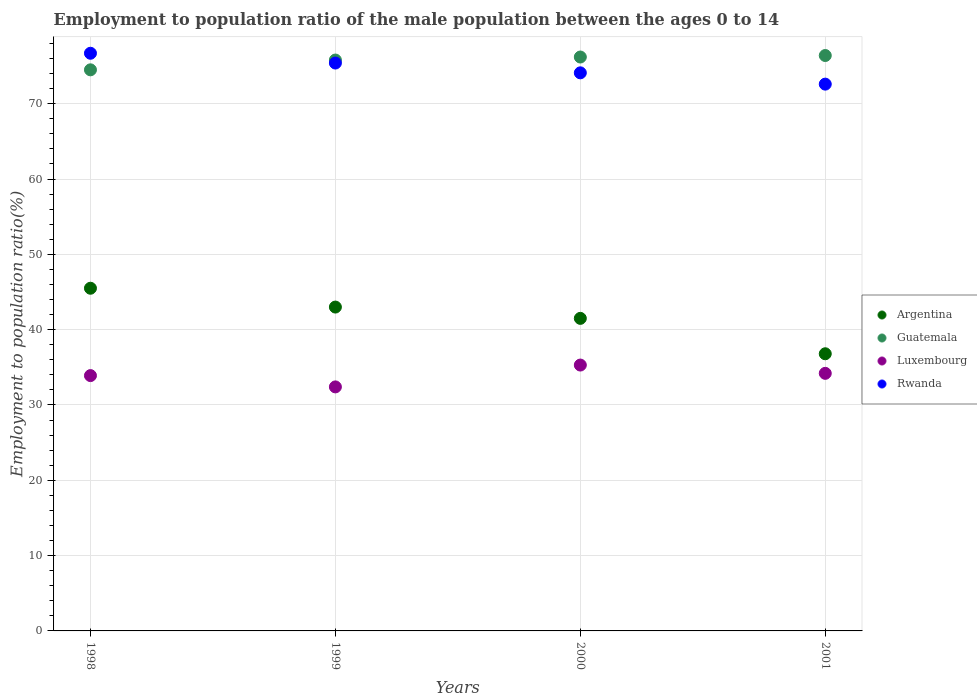What is the employment to population ratio in Argentina in 1998?
Offer a terse response. 45.5. Across all years, what is the maximum employment to population ratio in Rwanda?
Provide a short and direct response. 76.7. Across all years, what is the minimum employment to population ratio in Rwanda?
Your response must be concise. 72.6. In which year was the employment to population ratio in Argentina maximum?
Offer a very short reply. 1998. What is the total employment to population ratio in Luxembourg in the graph?
Your response must be concise. 135.8. What is the difference between the employment to population ratio in Rwanda in 1998 and that in 2001?
Offer a very short reply. 4.1. What is the difference between the employment to population ratio in Argentina in 1998 and the employment to population ratio in Guatemala in 2000?
Give a very brief answer. -30.7. What is the average employment to population ratio in Guatemala per year?
Provide a succinct answer. 75.73. In the year 1999, what is the difference between the employment to population ratio in Guatemala and employment to population ratio in Rwanda?
Offer a terse response. 0.4. In how many years, is the employment to population ratio in Argentina greater than 66 %?
Give a very brief answer. 0. What is the ratio of the employment to population ratio in Rwanda in 1998 to that in 2000?
Keep it short and to the point. 1.04. Is the employment to population ratio in Guatemala in 2000 less than that in 2001?
Provide a succinct answer. Yes. Is the difference between the employment to population ratio in Guatemala in 1998 and 1999 greater than the difference between the employment to population ratio in Rwanda in 1998 and 1999?
Give a very brief answer. No. What is the difference between the highest and the second highest employment to population ratio in Guatemala?
Provide a succinct answer. 0.2. What is the difference between the highest and the lowest employment to population ratio in Rwanda?
Provide a succinct answer. 4.1. Is it the case that in every year, the sum of the employment to population ratio in Argentina and employment to population ratio in Luxembourg  is greater than the employment to population ratio in Rwanda?
Offer a terse response. No. Are the values on the major ticks of Y-axis written in scientific E-notation?
Offer a terse response. No. Where does the legend appear in the graph?
Make the answer very short. Center right. What is the title of the graph?
Provide a short and direct response. Employment to population ratio of the male population between the ages 0 to 14. Does "Montenegro" appear as one of the legend labels in the graph?
Keep it short and to the point. No. What is the Employment to population ratio(%) of Argentina in 1998?
Provide a short and direct response. 45.5. What is the Employment to population ratio(%) in Guatemala in 1998?
Make the answer very short. 74.5. What is the Employment to population ratio(%) in Luxembourg in 1998?
Offer a very short reply. 33.9. What is the Employment to population ratio(%) of Rwanda in 1998?
Your response must be concise. 76.7. What is the Employment to population ratio(%) in Argentina in 1999?
Make the answer very short. 43. What is the Employment to population ratio(%) of Guatemala in 1999?
Your answer should be compact. 75.8. What is the Employment to population ratio(%) of Luxembourg in 1999?
Offer a very short reply. 32.4. What is the Employment to population ratio(%) in Rwanda in 1999?
Ensure brevity in your answer.  75.4. What is the Employment to population ratio(%) of Argentina in 2000?
Make the answer very short. 41.5. What is the Employment to population ratio(%) in Guatemala in 2000?
Your answer should be very brief. 76.2. What is the Employment to population ratio(%) in Luxembourg in 2000?
Provide a short and direct response. 35.3. What is the Employment to population ratio(%) in Rwanda in 2000?
Give a very brief answer. 74.1. What is the Employment to population ratio(%) in Argentina in 2001?
Give a very brief answer. 36.8. What is the Employment to population ratio(%) of Guatemala in 2001?
Your answer should be very brief. 76.4. What is the Employment to population ratio(%) of Luxembourg in 2001?
Keep it short and to the point. 34.2. What is the Employment to population ratio(%) in Rwanda in 2001?
Make the answer very short. 72.6. Across all years, what is the maximum Employment to population ratio(%) of Argentina?
Provide a succinct answer. 45.5. Across all years, what is the maximum Employment to population ratio(%) of Guatemala?
Provide a succinct answer. 76.4. Across all years, what is the maximum Employment to population ratio(%) in Luxembourg?
Make the answer very short. 35.3. Across all years, what is the maximum Employment to population ratio(%) of Rwanda?
Your answer should be very brief. 76.7. Across all years, what is the minimum Employment to population ratio(%) of Argentina?
Your answer should be compact. 36.8. Across all years, what is the minimum Employment to population ratio(%) of Guatemala?
Ensure brevity in your answer.  74.5. Across all years, what is the minimum Employment to population ratio(%) in Luxembourg?
Your answer should be compact. 32.4. Across all years, what is the minimum Employment to population ratio(%) of Rwanda?
Your response must be concise. 72.6. What is the total Employment to population ratio(%) of Argentina in the graph?
Offer a terse response. 166.8. What is the total Employment to population ratio(%) of Guatemala in the graph?
Provide a succinct answer. 302.9. What is the total Employment to population ratio(%) in Luxembourg in the graph?
Make the answer very short. 135.8. What is the total Employment to population ratio(%) in Rwanda in the graph?
Offer a very short reply. 298.8. What is the difference between the Employment to population ratio(%) in Luxembourg in 1998 and that in 1999?
Keep it short and to the point. 1.5. What is the difference between the Employment to population ratio(%) of Argentina in 1998 and that in 2000?
Ensure brevity in your answer.  4. What is the difference between the Employment to population ratio(%) in Guatemala in 1998 and that in 2000?
Your answer should be compact. -1.7. What is the difference between the Employment to population ratio(%) in Luxembourg in 1998 and that in 2000?
Your response must be concise. -1.4. What is the difference between the Employment to population ratio(%) in Rwanda in 1998 and that in 2000?
Your answer should be very brief. 2.6. What is the difference between the Employment to population ratio(%) of Argentina in 1998 and that in 2001?
Provide a succinct answer. 8.7. What is the difference between the Employment to population ratio(%) in Guatemala in 1998 and that in 2001?
Offer a terse response. -1.9. What is the difference between the Employment to population ratio(%) in Luxembourg in 1998 and that in 2001?
Offer a terse response. -0.3. What is the difference between the Employment to population ratio(%) in Rwanda in 1998 and that in 2001?
Ensure brevity in your answer.  4.1. What is the difference between the Employment to population ratio(%) in Luxembourg in 1999 and that in 2000?
Make the answer very short. -2.9. What is the difference between the Employment to population ratio(%) of Luxembourg in 1999 and that in 2001?
Offer a terse response. -1.8. What is the difference between the Employment to population ratio(%) in Rwanda in 1999 and that in 2001?
Give a very brief answer. 2.8. What is the difference between the Employment to population ratio(%) in Guatemala in 2000 and that in 2001?
Provide a succinct answer. -0.2. What is the difference between the Employment to population ratio(%) of Luxembourg in 2000 and that in 2001?
Give a very brief answer. 1.1. What is the difference between the Employment to population ratio(%) of Rwanda in 2000 and that in 2001?
Provide a succinct answer. 1.5. What is the difference between the Employment to population ratio(%) in Argentina in 1998 and the Employment to population ratio(%) in Guatemala in 1999?
Offer a terse response. -30.3. What is the difference between the Employment to population ratio(%) of Argentina in 1998 and the Employment to population ratio(%) of Rwanda in 1999?
Offer a very short reply. -29.9. What is the difference between the Employment to population ratio(%) of Guatemala in 1998 and the Employment to population ratio(%) of Luxembourg in 1999?
Your response must be concise. 42.1. What is the difference between the Employment to population ratio(%) of Guatemala in 1998 and the Employment to population ratio(%) of Rwanda in 1999?
Ensure brevity in your answer.  -0.9. What is the difference between the Employment to population ratio(%) of Luxembourg in 1998 and the Employment to population ratio(%) of Rwanda in 1999?
Your response must be concise. -41.5. What is the difference between the Employment to population ratio(%) in Argentina in 1998 and the Employment to population ratio(%) in Guatemala in 2000?
Provide a short and direct response. -30.7. What is the difference between the Employment to population ratio(%) in Argentina in 1998 and the Employment to population ratio(%) in Rwanda in 2000?
Ensure brevity in your answer.  -28.6. What is the difference between the Employment to population ratio(%) in Guatemala in 1998 and the Employment to population ratio(%) in Luxembourg in 2000?
Your answer should be very brief. 39.2. What is the difference between the Employment to population ratio(%) of Guatemala in 1998 and the Employment to population ratio(%) of Rwanda in 2000?
Offer a very short reply. 0.4. What is the difference between the Employment to population ratio(%) in Luxembourg in 1998 and the Employment to population ratio(%) in Rwanda in 2000?
Keep it short and to the point. -40.2. What is the difference between the Employment to population ratio(%) in Argentina in 1998 and the Employment to population ratio(%) in Guatemala in 2001?
Your answer should be very brief. -30.9. What is the difference between the Employment to population ratio(%) of Argentina in 1998 and the Employment to population ratio(%) of Luxembourg in 2001?
Keep it short and to the point. 11.3. What is the difference between the Employment to population ratio(%) of Argentina in 1998 and the Employment to population ratio(%) of Rwanda in 2001?
Offer a terse response. -27.1. What is the difference between the Employment to population ratio(%) in Guatemala in 1998 and the Employment to population ratio(%) in Luxembourg in 2001?
Provide a short and direct response. 40.3. What is the difference between the Employment to population ratio(%) in Guatemala in 1998 and the Employment to population ratio(%) in Rwanda in 2001?
Provide a succinct answer. 1.9. What is the difference between the Employment to population ratio(%) in Luxembourg in 1998 and the Employment to population ratio(%) in Rwanda in 2001?
Provide a succinct answer. -38.7. What is the difference between the Employment to population ratio(%) in Argentina in 1999 and the Employment to population ratio(%) in Guatemala in 2000?
Keep it short and to the point. -33.2. What is the difference between the Employment to population ratio(%) of Argentina in 1999 and the Employment to population ratio(%) of Rwanda in 2000?
Offer a very short reply. -31.1. What is the difference between the Employment to population ratio(%) in Guatemala in 1999 and the Employment to population ratio(%) in Luxembourg in 2000?
Offer a very short reply. 40.5. What is the difference between the Employment to population ratio(%) in Guatemala in 1999 and the Employment to population ratio(%) in Rwanda in 2000?
Give a very brief answer. 1.7. What is the difference between the Employment to population ratio(%) of Luxembourg in 1999 and the Employment to population ratio(%) of Rwanda in 2000?
Your answer should be very brief. -41.7. What is the difference between the Employment to population ratio(%) of Argentina in 1999 and the Employment to population ratio(%) of Guatemala in 2001?
Your answer should be compact. -33.4. What is the difference between the Employment to population ratio(%) of Argentina in 1999 and the Employment to population ratio(%) of Luxembourg in 2001?
Provide a short and direct response. 8.8. What is the difference between the Employment to population ratio(%) in Argentina in 1999 and the Employment to population ratio(%) in Rwanda in 2001?
Offer a terse response. -29.6. What is the difference between the Employment to population ratio(%) in Guatemala in 1999 and the Employment to population ratio(%) in Luxembourg in 2001?
Provide a short and direct response. 41.6. What is the difference between the Employment to population ratio(%) of Luxembourg in 1999 and the Employment to population ratio(%) of Rwanda in 2001?
Offer a very short reply. -40.2. What is the difference between the Employment to population ratio(%) in Argentina in 2000 and the Employment to population ratio(%) in Guatemala in 2001?
Provide a succinct answer. -34.9. What is the difference between the Employment to population ratio(%) of Argentina in 2000 and the Employment to population ratio(%) of Rwanda in 2001?
Make the answer very short. -31.1. What is the difference between the Employment to population ratio(%) in Guatemala in 2000 and the Employment to population ratio(%) in Luxembourg in 2001?
Ensure brevity in your answer.  42. What is the difference between the Employment to population ratio(%) in Guatemala in 2000 and the Employment to population ratio(%) in Rwanda in 2001?
Provide a succinct answer. 3.6. What is the difference between the Employment to population ratio(%) in Luxembourg in 2000 and the Employment to population ratio(%) in Rwanda in 2001?
Give a very brief answer. -37.3. What is the average Employment to population ratio(%) of Argentina per year?
Offer a terse response. 41.7. What is the average Employment to population ratio(%) of Guatemala per year?
Keep it short and to the point. 75.72. What is the average Employment to population ratio(%) of Luxembourg per year?
Give a very brief answer. 33.95. What is the average Employment to population ratio(%) of Rwanda per year?
Make the answer very short. 74.7. In the year 1998, what is the difference between the Employment to population ratio(%) of Argentina and Employment to population ratio(%) of Rwanda?
Your answer should be very brief. -31.2. In the year 1998, what is the difference between the Employment to population ratio(%) of Guatemala and Employment to population ratio(%) of Luxembourg?
Make the answer very short. 40.6. In the year 1998, what is the difference between the Employment to population ratio(%) of Guatemala and Employment to population ratio(%) of Rwanda?
Make the answer very short. -2.2. In the year 1998, what is the difference between the Employment to population ratio(%) of Luxembourg and Employment to population ratio(%) of Rwanda?
Offer a very short reply. -42.8. In the year 1999, what is the difference between the Employment to population ratio(%) in Argentina and Employment to population ratio(%) in Guatemala?
Offer a terse response. -32.8. In the year 1999, what is the difference between the Employment to population ratio(%) of Argentina and Employment to population ratio(%) of Luxembourg?
Give a very brief answer. 10.6. In the year 1999, what is the difference between the Employment to population ratio(%) of Argentina and Employment to population ratio(%) of Rwanda?
Offer a very short reply. -32.4. In the year 1999, what is the difference between the Employment to population ratio(%) of Guatemala and Employment to population ratio(%) of Luxembourg?
Your answer should be very brief. 43.4. In the year 1999, what is the difference between the Employment to population ratio(%) in Guatemala and Employment to population ratio(%) in Rwanda?
Your answer should be compact. 0.4. In the year 1999, what is the difference between the Employment to population ratio(%) of Luxembourg and Employment to population ratio(%) of Rwanda?
Offer a very short reply. -43. In the year 2000, what is the difference between the Employment to population ratio(%) in Argentina and Employment to population ratio(%) in Guatemala?
Your response must be concise. -34.7. In the year 2000, what is the difference between the Employment to population ratio(%) in Argentina and Employment to population ratio(%) in Rwanda?
Offer a terse response. -32.6. In the year 2000, what is the difference between the Employment to population ratio(%) in Guatemala and Employment to population ratio(%) in Luxembourg?
Offer a very short reply. 40.9. In the year 2000, what is the difference between the Employment to population ratio(%) in Luxembourg and Employment to population ratio(%) in Rwanda?
Your response must be concise. -38.8. In the year 2001, what is the difference between the Employment to population ratio(%) of Argentina and Employment to population ratio(%) of Guatemala?
Ensure brevity in your answer.  -39.6. In the year 2001, what is the difference between the Employment to population ratio(%) of Argentina and Employment to population ratio(%) of Luxembourg?
Provide a short and direct response. 2.6. In the year 2001, what is the difference between the Employment to population ratio(%) in Argentina and Employment to population ratio(%) in Rwanda?
Ensure brevity in your answer.  -35.8. In the year 2001, what is the difference between the Employment to population ratio(%) in Guatemala and Employment to population ratio(%) in Luxembourg?
Keep it short and to the point. 42.2. In the year 2001, what is the difference between the Employment to population ratio(%) in Luxembourg and Employment to population ratio(%) in Rwanda?
Keep it short and to the point. -38.4. What is the ratio of the Employment to population ratio(%) of Argentina in 1998 to that in 1999?
Your answer should be very brief. 1.06. What is the ratio of the Employment to population ratio(%) of Guatemala in 1998 to that in 1999?
Your answer should be compact. 0.98. What is the ratio of the Employment to population ratio(%) in Luxembourg in 1998 to that in 1999?
Give a very brief answer. 1.05. What is the ratio of the Employment to population ratio(%) in Rwanda in 1998 to that in 1999?
Your response must be concise. 1.02. What is the ratio of the Employment to population ratio(%) in Argentina in 1998 to that in 2000?
Offer a very short reply. 1.1. What is the ratio of the Employment to population ratio(%) of Guatemala in 1998 to that in 2000?
Provide a succinct answer. 0.98. What is the ratio of the Employment to population ratio(%) in Luxembourg in 1998 to that in 2000?
Offer a terse response. 0.96. What is the ratio of the Employment to population ratio(%) of Rwanda in 1998 to that in 2000?
Keep it short and to the point. 1.04. What is the ratio of the Employment to population ratio(%) of Argentina in 1998 to that in 2001?
Keep it short and to the point. 1.24. What is the ratio of the Employment to population ratio(%) of Guatemala in 1998 to that in 2001?
Provide a succinct answer. 0.98. What is the ratio of the Employment to population ratio(%) of Luxembourg in 1998 to that in 2001?
Your answer should be compact. 0.99. What is the ratio of the Employment to population ratio(%) in Rwanda in 1998 to that in 2001?
Your response must be concise. 1.06. What is the ratio of the Employment to population ratio(%) in Argentina in 1999 to that in 2000?
Offer a terse response. 1.04. What is the ratio of the Employment to population ratio(%) of Luxembourg in 1999 to that in 2000?
Make the answer very short. 0.92. What is the ratio of the Employment to population ratio(%) in Rwanda in 1999 to that in 2000?
Ensure brevity in your answer.  1.02. What is the ratio of the Employment to population ratio(%) of Argentina in 1999 to that in 2001?
Your answer should be compact. 1.17. What is the ratio of the Employment to population ratio(%) of Guatemala in 1999 to that in 2001?
Offer a very short reply. 0.99. What is the ratio of the Employment to population ratio(%) of Rwanda in 1999 to that in 2001?
Keep it short and to the point. 1.04. What is the ratio of the Employment to population ratio(%) of Argentina in 2000 to that in 2001?
Make the answer very short. 1.13. What is the ratio of the Employment to population ratio(%) of Luxembourg in 2000 to that in 2001?
Offer a very short reply. 1.03. What is the ratio of the Employment to population ratio(%) of Rwanda in 2000 to that in 2001?
Keep it short and to the point. 1.02. What is the difference between the highest and the second highest Employment to population ratio(%) in Argentina?
Your answer should be very brief. 2.5. What is the difference between the highest and the second highest Employment to population ratio(%) of Luxembourg?
Your answer should be very brief. 1.1. What is the difference between the highest and the second highest Employment to population ratio(%) of Rwanda?
Offer a terse response. 1.3. What is the difference between the highest and the lowest Employment to population ratio(%) of Argentina?
Your response must be concise. 8.7. What is the difference between the highest and the lowest Employment to population ratio(%) in Rwanda?
Give a very brief answer. 4.1. 